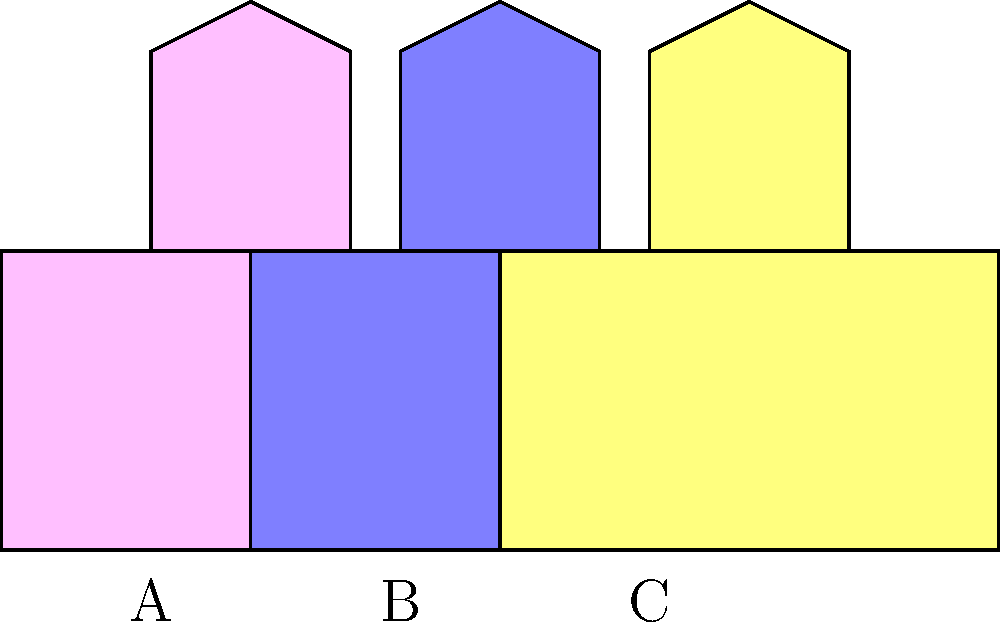In the illustration above, which traditional Korean clothing element is represented, and which drama genre would likely feature these costumes? To answer this question, let's break it down step-by-step:

1. Identify the clothing: The illustration shows three similar outfits in different colors (pink, light blue, and light yellow).

2. Recognize the key features:
   - A short jacket-like top with long sleeves
   - A long, high-waisted skirt that flares out
   - The overall silhouette is wide at the bottom and narrow at the top

3. Match these features to traditional Korean clothing:
   These characteristics are typical of the Hanbok, the traditional Korean attire.

4. Consider the drama genre:
   - Hanboks are often featured in historical or period dramas
   - These dramas are known as "sageuk" in Korean

5. Connect to K-dramas:
   Many popular K-dramas, especially those set in historical periods or featuring royal characters, showcase Hanboks.

Therefore, the clothing element represented is the Hanbok, and these costumes would likely be featured in historical or period K-dramas, known as "sageuk."
Answer: Hanbok; Sageuk (historical/period drama) 